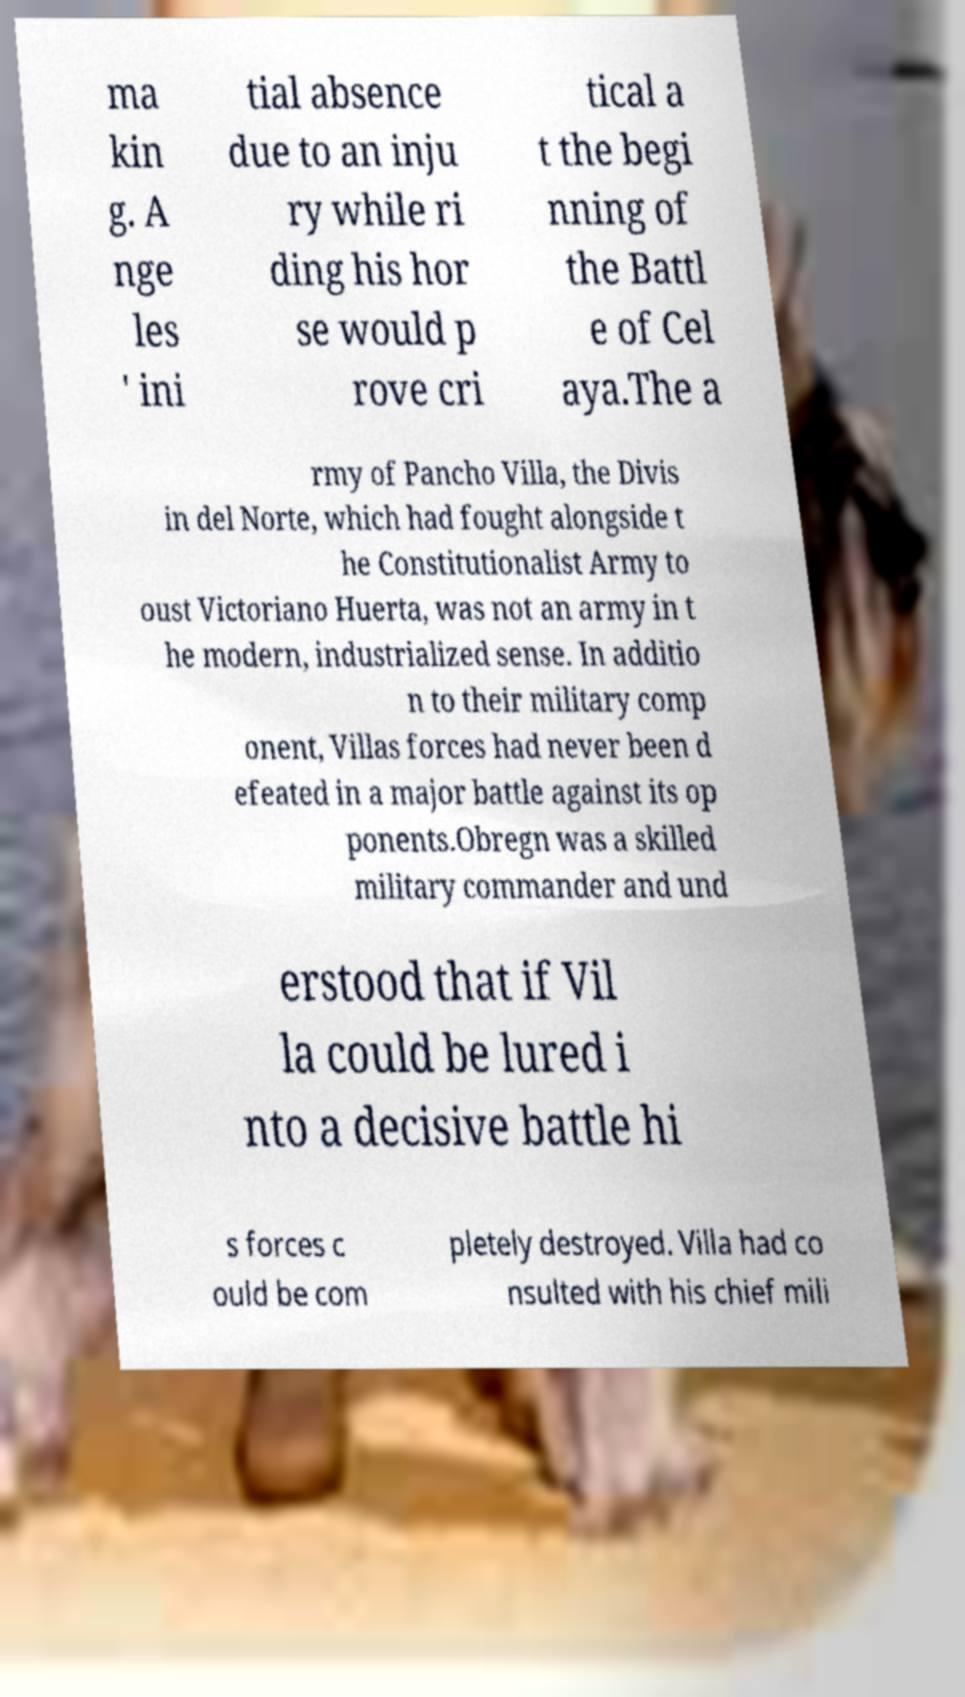Could you assist in decoding the text presented in this image and type it out clearly? ma kin g. A nge les ' ini tial absence due to an inju ry while ri ding his hor se would p rove cri tical a t the begi nning of the Battl e of Cel aya.The a rmy of Pancho Villa, the Divis in del Norte, which had fought alongside t he Constitutionalist Army to oust Victoriano Huerta, was not an army in t he modern, industrialized sense. In additio n to their military comp onent, Villas forces had never been d efeated in a major battle against its op ponents.Obregn was a skilled military commander and und erstood that if Vil la could be lured i nto a decisive battle hi s forces c ould be com pletely destroyed. Villa had co nsulted with his chief mili 